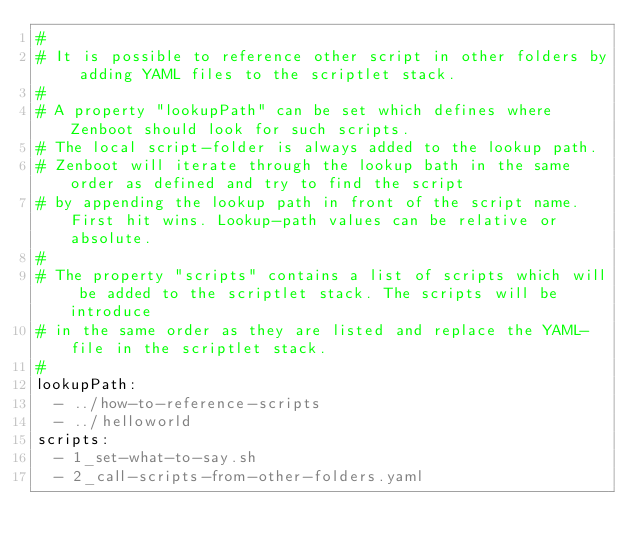<code> <loc_0><loc_0><loc_500><loc_500><_YAML_>#
# It is possible to reference other script in other folders by adding YAML files to the scriptlet stack.
#
# A property "lookupPath" can be set which defines where Zenboot should look for such scripts.
# The local script-folder is always added to the lookup path.
# Zenboot will iterate through the lookup bath in the same order as defined and try to find the script
# by appending the lookup path in front of the script name. First hit wins. Lookup-path values can be relative or absolute.
#
# The property "scripts" contains a list of scripts which will be added to the scriptlet stack. The scripts will be introduce
# in the same order as they are listed and replace the YAML-file in the scriptlet stack.
#
lookupPath:
  - ../how-to-reference-scripts
  - ../helloworld
scripts:
  - 1_set-what-to-say.sh
  - 2_call-scripts-from-other-folders.yaml
</code> 